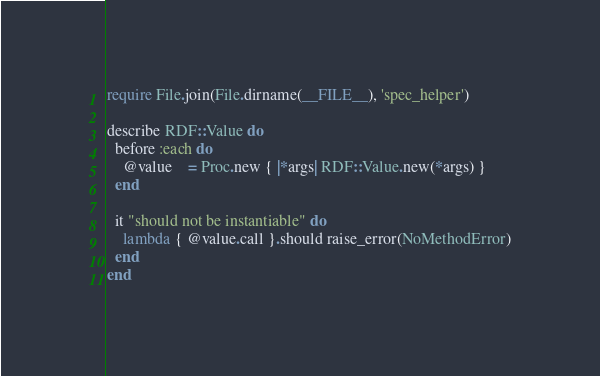<code> <loc_0><loc_0><loc_500><loc_500><_Ruby_>require File.join(File.dirname(__FILE__), 'spec_helper')

describe RDF::Value do
  before :each do
    @value    = Proc.new { |*args| RDF::Value.new(*args) }
  end

  it "should not be instantiable" do
    lambda { @value.call }.should raise_error(NoMethodError)
  end
end
</code> 